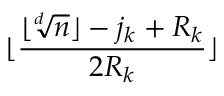Convert formula to latex. <formula><loc_0><loc_0><loc_500><loc_500>\lfloor \frac { \lfloor \sqrt { [ } d ] { n } \rfloor - j _ { k } + R _ { k } } { 2 R _ { k } } \rfloor</formula> 